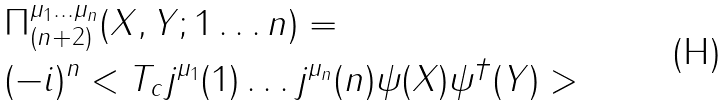<formula> <loc_0><loc_0><loc_500><loc_500>& \Pi _ { ( n + 2 ) } ^ { \mu _ { 1 } \dots \mu _ { n } } ( X , Y ; 1 \dots n ) = \\ & ( - i ) ^ { n } < T _ { c } j ^ { \mu _ { 1 } } ( 1 ) \dots j ^ { \mu _ { n } } ( n ) \psi ( X ) \psi ^ { \dagger } ( Y ) ></formula> 